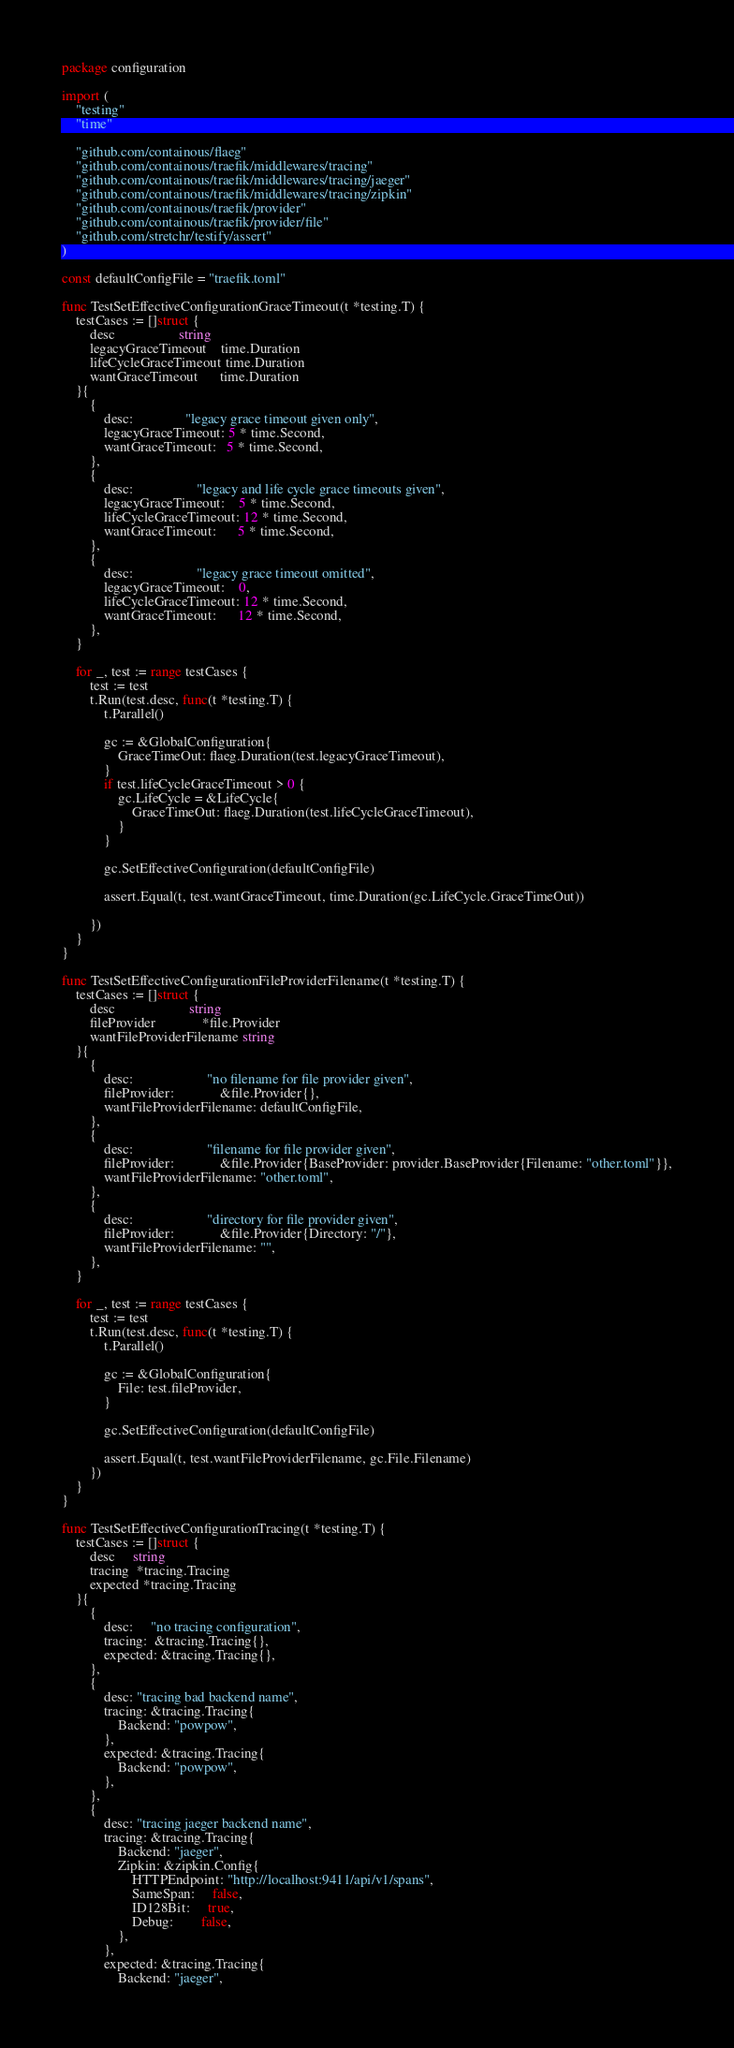Convert code to text. <code><loc_0><loc_0><loc_500><loc_500><_Go_>package configuration

import (
	"testing"
	"time"

	"github.com/containous/flaeg"
	"github.com/containous/traefik/middlewares/tracing"
	"github.com/containous/traefik/middlewares/tracing/jaeger"
	"github.com/containous/traefik/middlewares/tracing/zipkin"
	"github.com/containous/traefik/provider"
	"github.com/containous/traefik/provider/file"
	"github.com/stretchr/testify/assert"
)

const defaultConfigFile = "traefik.toml"

func TestSetEffectiveConfigurationGraceTimeout(t *testing.T) {
	testCases := []struct {
		desc                  string
		legacyGraceTimeout    time.Duration
		lifeCycleGraceTimeout time.Duration
		wantGraceTimeout      time.Duration
	}{
		{
			desc:               "legacy grace timeout given only",
			legacyGraceTimeout: 5 * time.Second,
			wantGraceTimeout:   5 * time.Second,
		},
		{
			desc:                  "legacy and life cycle grace timeouts given",
			legacyGraceTimeout:    5 * time.Second,
			lifeCycleGraceTimeout: 12 * time.Second,
			wantGraceTimeout:      5 * time.Second,
		},
		{
			desc:                  "legacy grace timeout omitted",
			legacyGraceTimeout:    0,
			lifeCycleGraceTimeout: 12 * time.Second,
			wantGraceTimeout:      12 * time.Second,
		},
	}

	for _, test := range testCases {
		test := test
		t.Run(test.desc, func(t *testing.T) {
			t.Parallel()

			gc := &GlobalConfiguration{
				GraceTimeOut: flaeg.Duration(test.legacyGraceTimeout),
			}
			if test.lifeCycleGraceTimeout > 0 {
				gc.LifeCycle = &LifeCycle{
					GraceTimeOut: flaeg.Duration(test.lifeCycleGraceTimeout),
				}
			}

			gc.SetEffectiveConfiguration(defaultConfigFile)

			assert.Equal(t, test.wantGraceTimeout, time.Duration(gc.LifeCycle.GraceTimeOut))

		})
	}
}

func TestSetEffectiveConfigurationFileProviderFilename(t *testing.T) {
	testCases := []struct {
		desc                     string
		fileProvider             *file.Provider
		wantFileProviderFilename string
	}{
		{
			desc:                     "no filename for file provider given",
			fileProvider:             &file.Provider{},
			wantFileProviderFilename: defaultConfigFile,
		},
		{
			desc:                     "filename for file provider given",
			fileProvider:             &file.Provider{BaseProvider: provider.BaseProvider{Filename: "other.toml"}},
			wantFileProviderFilename: "other.toml",
		},
		{
			desc:                     "directory for file provider given",
			fileProvider:             &file.Provider{Directory: "/"},
			wantFileProviderFilename: "",
		},
	}

	for _, test := range testCases {
		test := test
		t.Run(test.desc, func(t *testing.T) {
			t.Parallel()

			gc := &GlobalConfiguration{
				File: test.fileProvider,
			}

			gc.SetEffectiveConfiguration(defaultConfigFile)

			assert.Equal(t, test.wantFileProviderFilename, gc.File.Filename)
		})
	}
}

func TestSetEffectiveConfigurationTracing(t *testing.T) {
	testCases := []struct {
		desc     string
		tracing  *tracing.Tracing
		expected *tracing.Tracing
	}{
		{
			desc:     "no tracing configuration",
			tracing:  &tracing.Tracing{},
			expected: &tracing.Tracing{},
		},
		{
			desc: "tracing bad backend name",
			tracing: &tracing.Tracing{
				Backend: "powpow",
			},
			expected: &tracing.Tracing{
				Backend: "powpow",
			},
		},
		{
			desc: "tracing jaeger backend name",
			tracing: &tracing.Tracing{
				Backend: "jaeger",
				Zipkin: &zipkin.Config{
					HTTPEndpoint: "http://localhost:9411/api/v1/spans",
					SameSpan:     false,
					ID128Bit:     true,
					Debug:        false,
				},
			},
			expected: &tracing.Tracing{
				Backend: "jaeger",</code> 